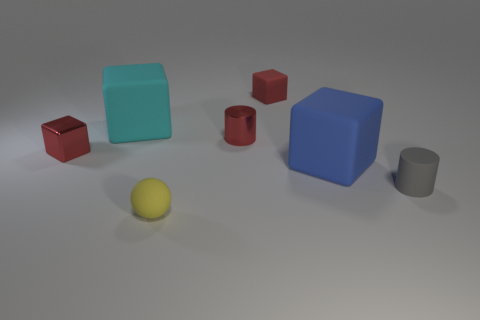Subtract all blue rubber blocks. How many blocks are left? 3 Subtract all red balls. How many red cubes are left? 2 Subtract 1 cubes. How many cubes are left? 3 Subtract all cyan blocks. How many blocks are left? 3 Add 2 tiny red shiny objects. How many objects exist? 9 Subtract all spheres. How many objects are left? 6 Subtract all gray cubes. Subtract all gray spheres. How many cubes are left? 4 Subtract all rubber spheres. Subtract all big gray metal cylinders. How many objects are left? 6 Add 6 yellow things. How many yellow things are left? 7 Add 3 shiny cubes. How many shiny cubes exist? 4 